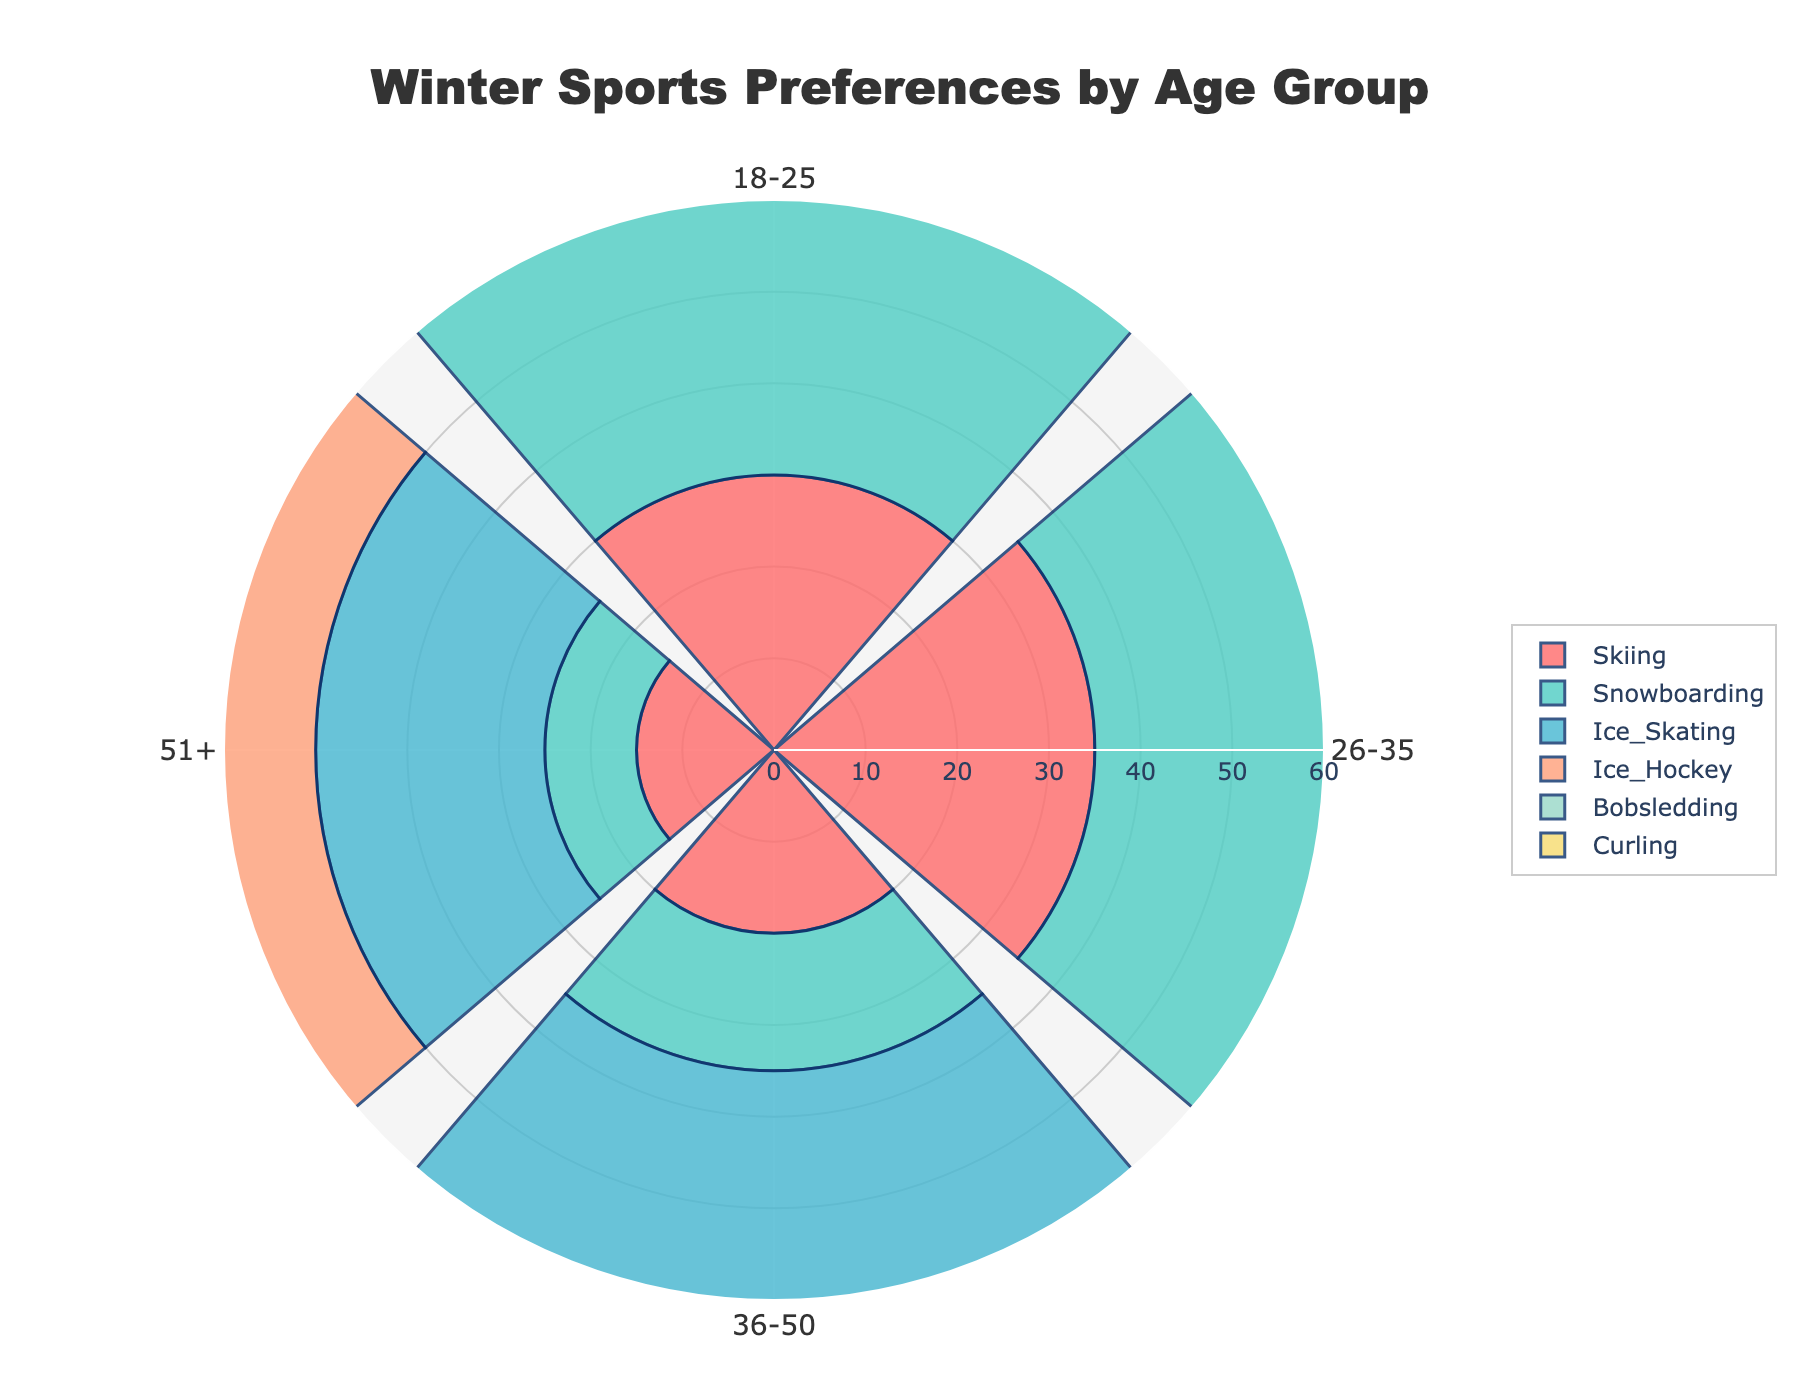Who prefers snowboarding the most? Identify the category "Snowboarding" and look at the age groups with the highest percentage. Here, the 18-25 age group has the highest preference.
Answer: 18-25 Which age group has the highest preference for curling? Look at the category "Curling" and find the age group with the highest percentage. The 51+ age group has the highest percentage.
Answer: 51+ What is the title of the chart? Look at the topmost text on the chart; it indicates the chart title. It reads "Winter Sports Preferences by Age Group."
Answer: Winter Sports Preferences by Age Group Which sport has the most equal distribution of preferences across all age groups? Compare the percentages across age groups for each sport. Ice Hockey shows similar values across different age groups.
Answer: Ice Hockey Which sport is least preferred by the 18-25 age group? Check the percentages for each sport within the 18-25 age group. Curling has the lowest percentage.
Answer: Curling For the age group 36-50, what is the sum of percentages for skiing and bobsledding? Look at the percentages for skiing (20%) and bobsledding (35%) in the 36-50 age group and add them up. 20 + 35 = 55.
Answer: 55 Which age group has the highest cumulative preference for bobsledding and curling? Sum the percentages for bobsledding and curling in each age group. The 51+ age group has the highest cumulative preference: 40% (Bobsledding) + 60% (Curling) = 100%.
Answer: 51+ What is the color used to represent ice skating? Identify the visual marker color associated with the category labeled as "Ice Skating" in the chart.
Answer: Likely '#45B7D1' (light blue) Which age group sees a decline in percentage from skiing to snowboarding? Compare the percentages for skiing and snowboarding across all age groups. The 51+ age group shows a decline from 15% (Skiing) to 10% (Snowboarding).
Answer: 51+ Which sport category represents the smallest cumulative percentage across all age groups? Sum up the percentages for each sport across all age groups. Curling has the smallest cumulative percentage: 8 + 12 + 20 + 60 = 100.
Answer: Curling 